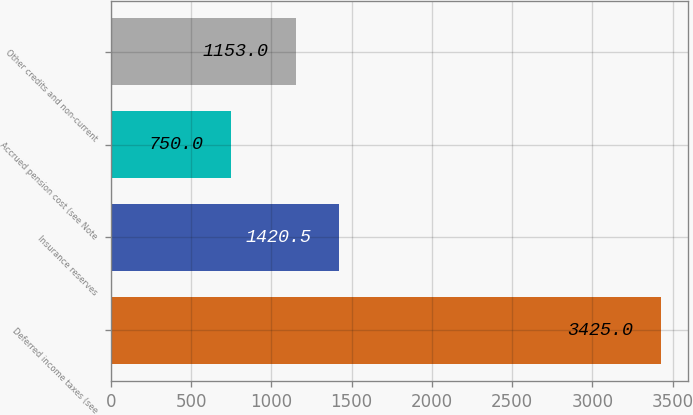<chart> <loc_0><loc_0><loc_500><loc_500><bar_chart><fcel>Deferred income taxes (see<fcel>Insurance reserves<fcel>Accrued pension cost (see Note<fcel>Other credits and non-current<nl><fcel>3425<fcel>1420.5<fcel>750<fcel>1153<nl></chart> 